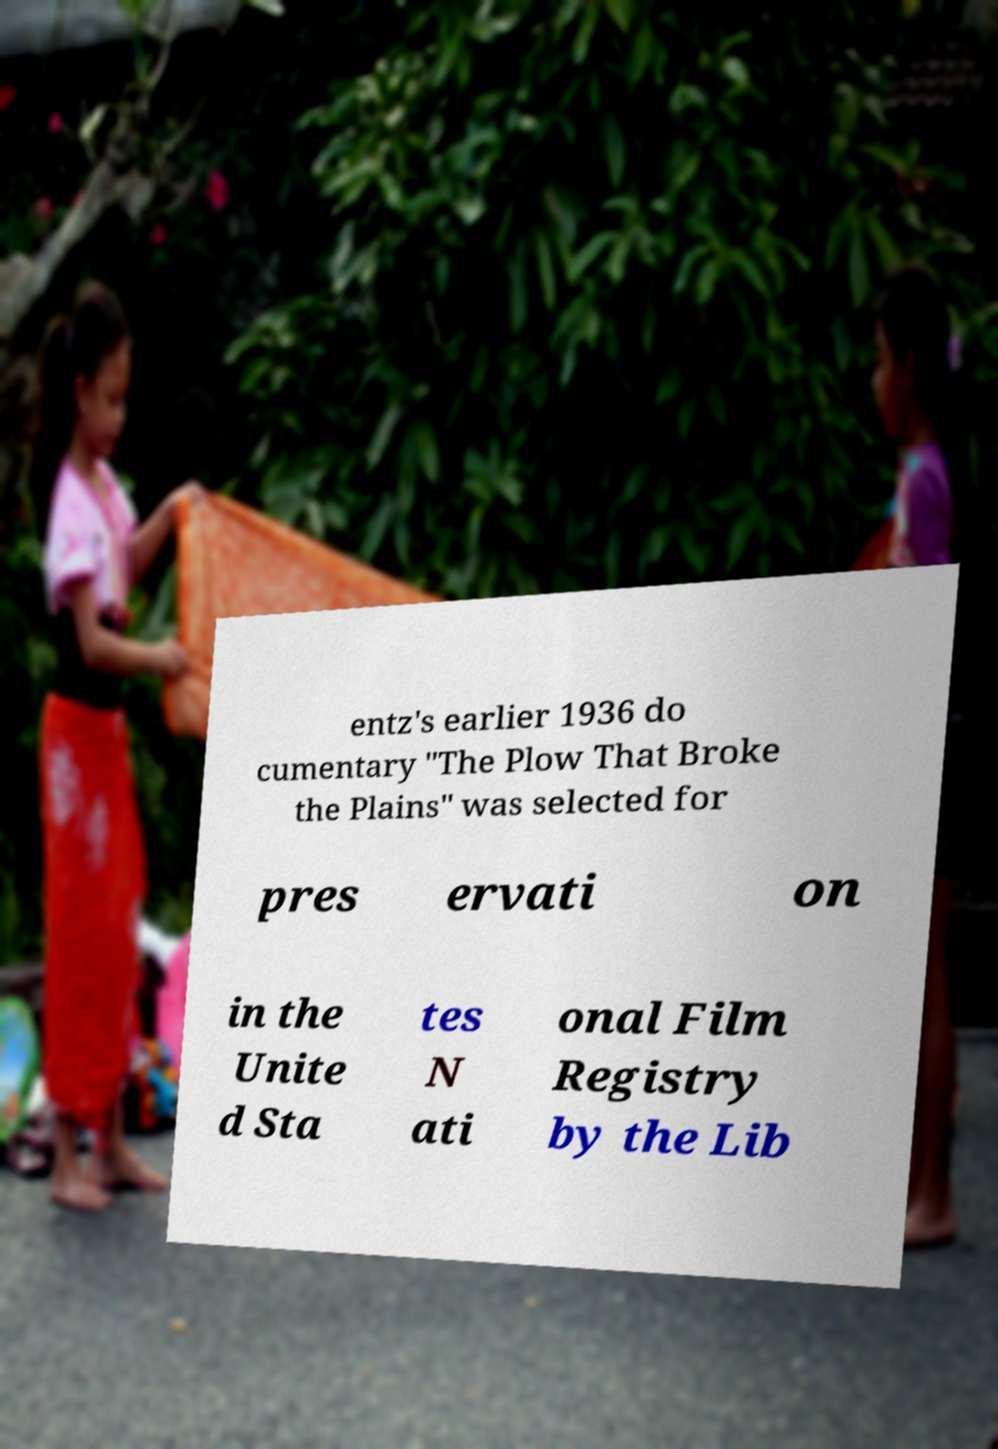What messages or text are displayed in this image? I need them in a readable, typed format. entz's earlier 1936 do cumentary "The Plow That Broke the Plains" was selected for pres ervati on in the Unite d Sta tes N ati onal Film Registry by the Lib 